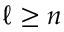<formula> <loc_0><loc_0><loc_500><loc_500>\ell \geq n</formula> 